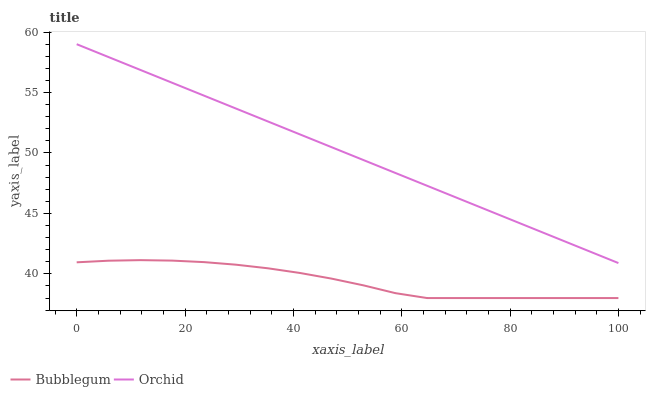Does Bubblegum have the minimum area under the curve?
Answer yes or no. Yes. Does Orchid have the maximum area under the curve?
Answer yes or no. Yes. Does Orchid have the minimum area under the curve?
Answer yes or no. No. Is Orchid the smoothest?
Answer yes or no. Yes. Is Bubblegum the roughest?
Answer yes or no. Yes. Is Orchid the roughest?
Answer yes or no. No. Does Bubblegum have the lowest value?
Answer yes or no. Yes. Does Orchid have the lowest value?
Answer yes or no. No. Does Orchid have the highest value?
Answer yes or no. Yes. Is Bubblegum less than Orchid?
Answer yes or no. Yes. Is Orchid greater than Bubblegum?
Answer yes or no. Yes. Does Bubblegum intersect Orchid?
Answer yes or no. No. 